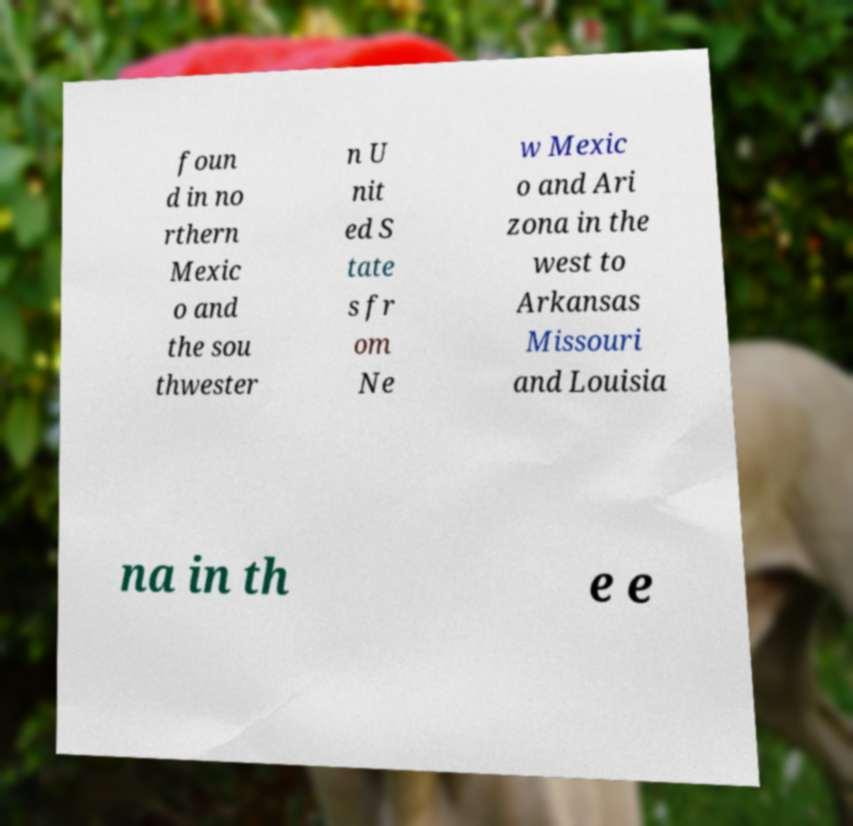Could you assist in decoding the text presented in this image and type it out clearly? foun d in no rthern Mexic o and the sou thwester n U nit ed S tate s fr om Ne w Mexic o and Ari zona in the west to Arkansas Missouri and Louisia na in th e e 